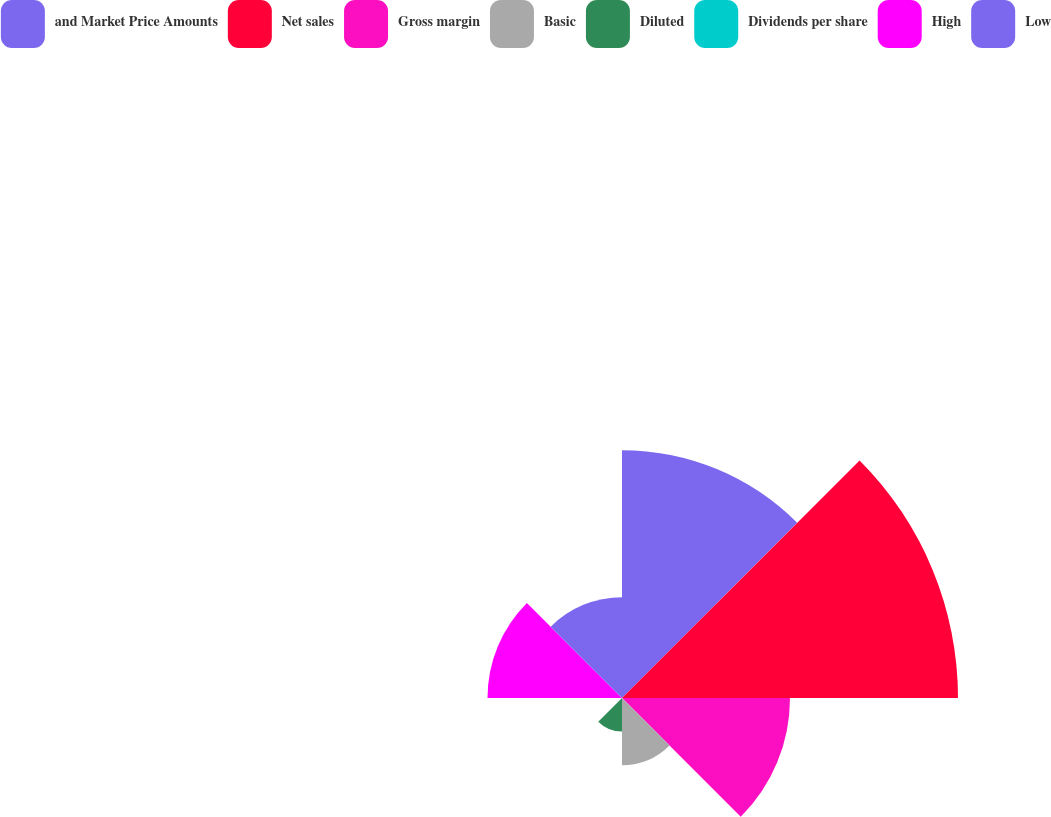Convert chart. <chart><loc_0><loc_0><loc_500><loc_500><pie_chart><fcel>and Market Price Amounts<fcel>Net sales<fcel>Gross margin<fcel>Basic<fcel>Diluted<fcel>Dividends per share<fcel>High<fcel>Low<nl><fcel>22.77%<fcel>30.88%<fcel>15.44%<fcel>6.18%<fcel>3.09%<fcel>0.0%<fcel>12.36%<fcel>9.27%<nl></chart> 